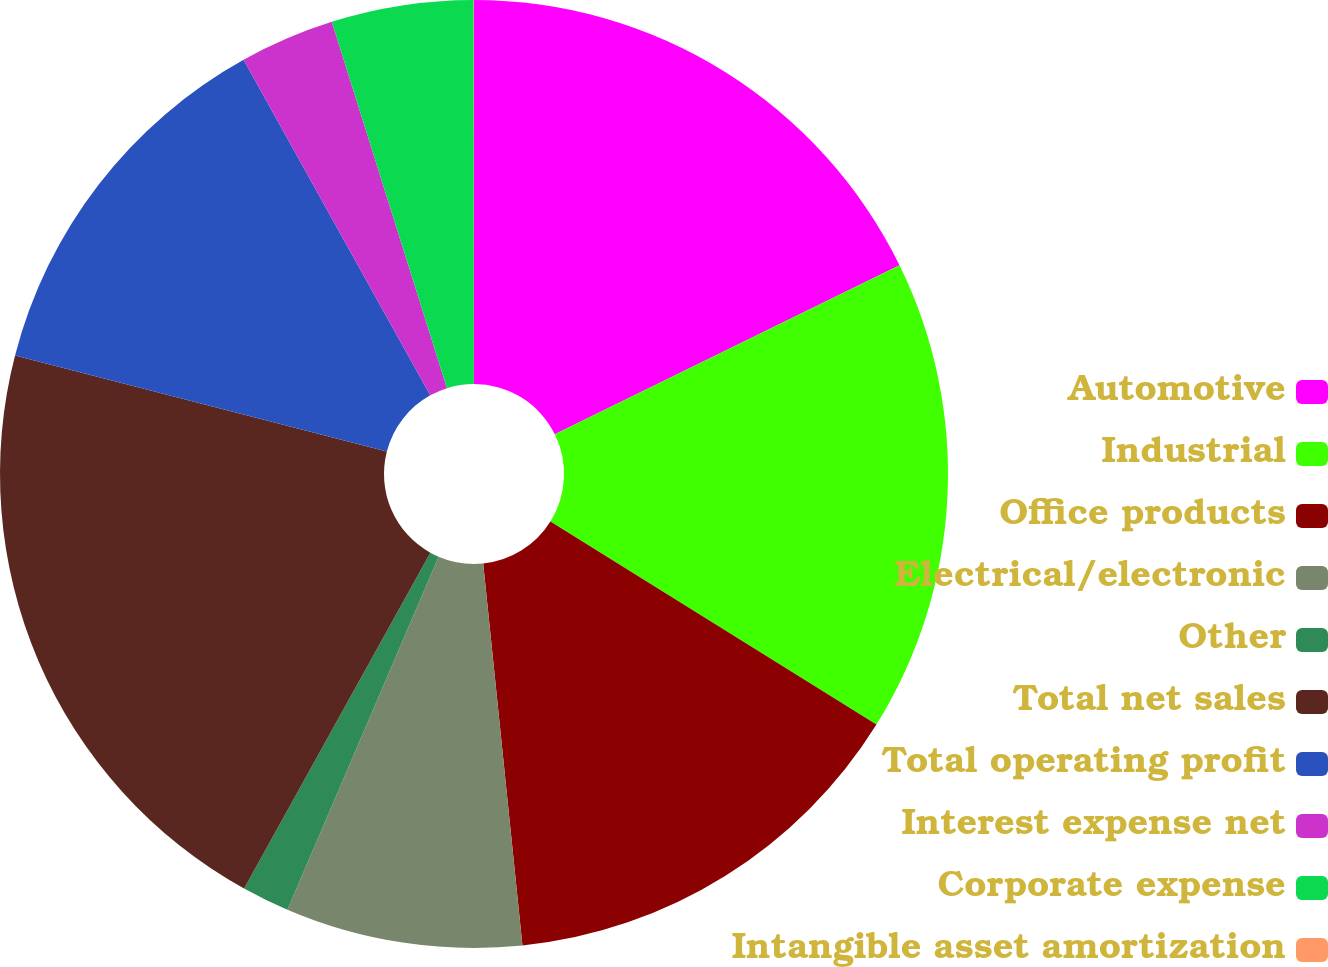<chart> <loc_0><loc_0><loc_500><loc_500><pie_chart><fcel>Automotive<fcel>Industrial<fcel>Office products<fcel>Electrical/electronic<fcel>Other<fcel>Total net sales<fcel>Total operating profit<fcel>Interest expense net<fcel>Corporate expense<fcel>Intangible asset amortization<nl><fcel>17.74%<fcel>16.12%<fcel>14.51%<fcel>8.07%<fcel>1.62%<fcel>20.96%<fcel>12.9%<fcel>3.23%<fcel>4.84%<fcel>0.01%<nl></chart> 